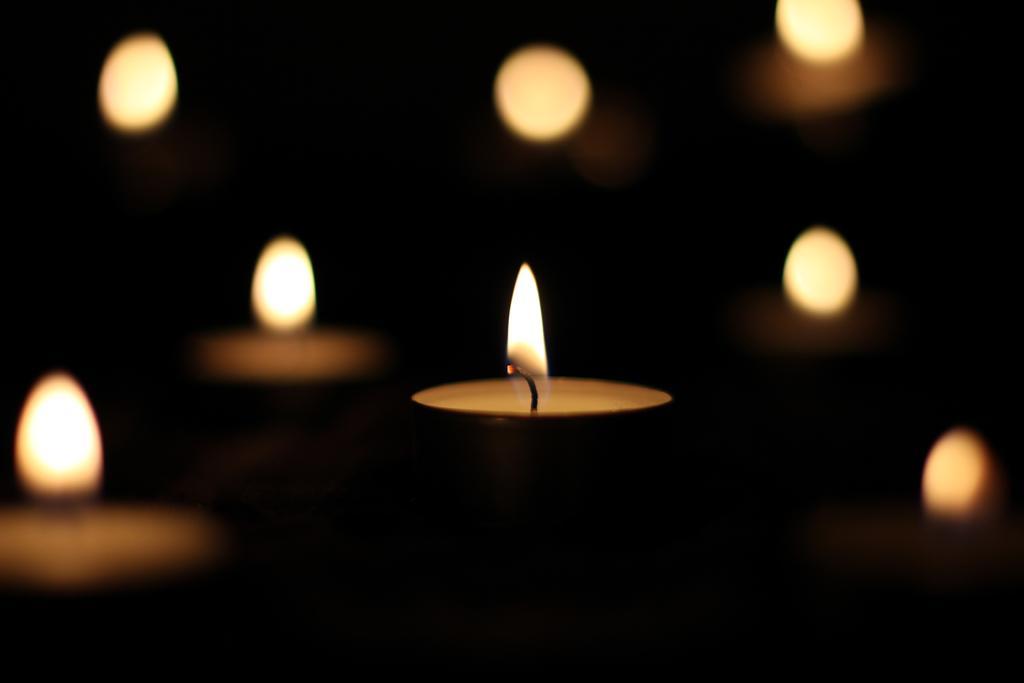Please provide a concise description of this image. In the image there are many lamps but only one lamp is highlighted among them. 